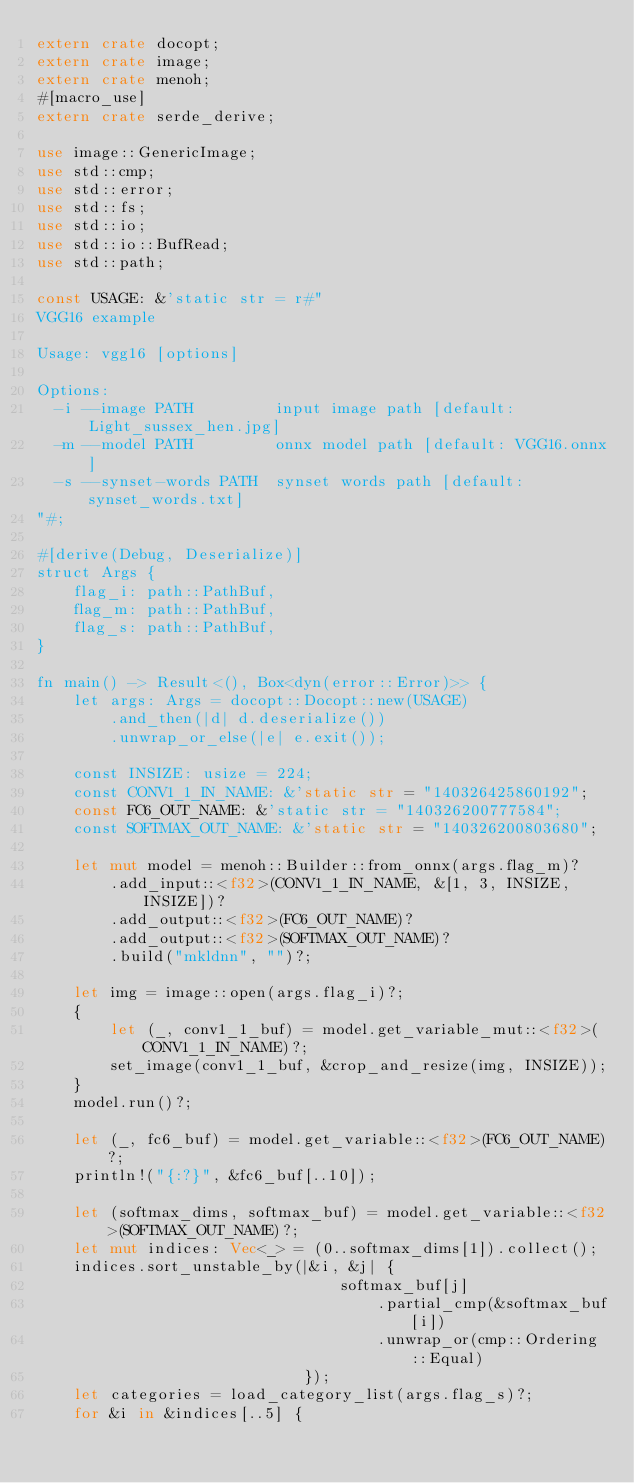<code> <loc_0><loc_0><loc_500><loc_500><_Rust_>extern crate docopt;
extern crate image;
extern crate menoh;
#[macro_use]
extern crate serde_derive;

use image::GenericImage;
use std::cmp;
use std::error;
use std::fs;
use std::io;
use std::io::BufRead;
use std::path;

const USAGE: &'static str = r#"
VGG16 example

Usage: vgg16 [options]

Options:
  -i --image PATH         input image path [default: Light_sussex_hen.jpg]
  -m --model PATH         onnx model path [default: VGG16.onnx]
  -s --synset-words PATH  synset words path [default: synset_words.txt]
"#;

#[derive(Debug, Deserialize)]
struct Args {
    flag_i: path::PathBuf,
    flag_m: path::PathBuf,
    flag_s: path::PathBuf,
}

fn main() -> Result<(), Box<dyn(error::Error)>> {
    let args: Args = docopt::Docopt::new(USAGE)
        .and_then(|d| d.deserialize())
        .unwrap_or_else(|e| e.exit());

    const INSIZE: usize = 224;
    const CONV1_1_IN_NAME: &'static str = "140326425860192";
    const FC6_OUT_NAME: &'static str = "140326200777584";
    const SOFTMAX_OUT_NAME: &'static str = "140326200803680";

    let mut model = menoh::Builder::from_onnx(args.flag_m)?
        .add_input::<f32>(CONV1_1_IN_NAME, &[1, 3, INSIZE, INSIZE])?
        .add_output::<f32>(FC6_OUT_NAME)?
        .add_output::<f32>(SOFTMAX_OUT_NAME)?
        .build("mkldnn", "")?;

    let img = image::open(args.flag_i)?;
    {
        let (_, conv1_1_buf) = model.get_variable_mut::<f32>(CONV1_1_IN_NAME)?;
        set_image(conv1_1_buf, &crop_and_resize(img, INSIZE));
    }
    model.run()?;

    let (_, fc6_buf) = model.get_variable::<f32>(FC6_OUT_NAME)?;
    println!("{:?}", &fc6_buf[..10]);

    let (softmax_dims, softmax_buf) = model.get_variable::<f32>(SOFTMAX_OUT_NAME)?;
    let mut indices: Vec<_> = (0..softmax_dims[1]).collect();
    indices.sort_unstable_by(|&i, &j| {
                                 softmax_buf[j]
                                     .partial_cmp(&softmax_buf[i])
                                     .unwrap_or(cmp::Ordering::Equal)
                             });
    let categories = load_category_list(args.flag_s)?;
    for &i in &indices[..5] {</code> 